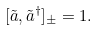<formula> <loc_0><loc_0><loc_500><loc_500>[ \tilde { a } , \tilde { a } ^ { \dagger } ] _ { \pm } = 1 .</formula> 